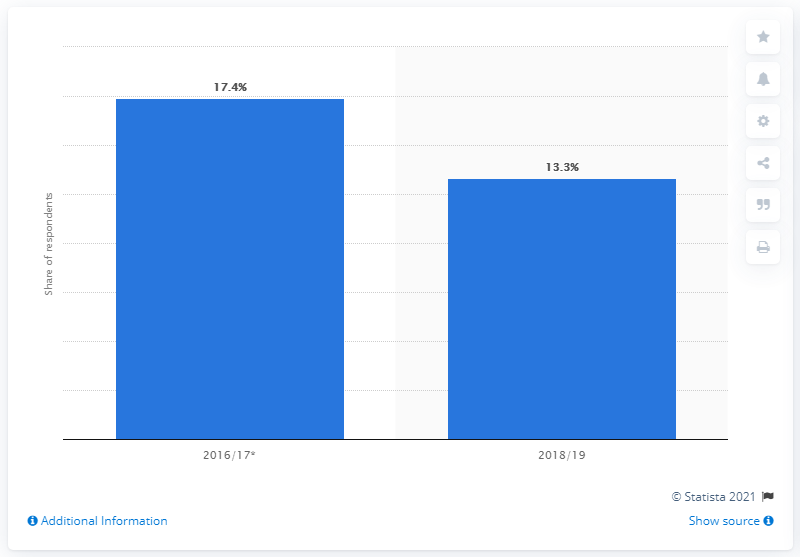Mention a couple of crucial points in this snapshot. According to a survey conducted in Colombia between 2018 and 2019, 13.3% of the population reported having been asked to pay a bribe. 